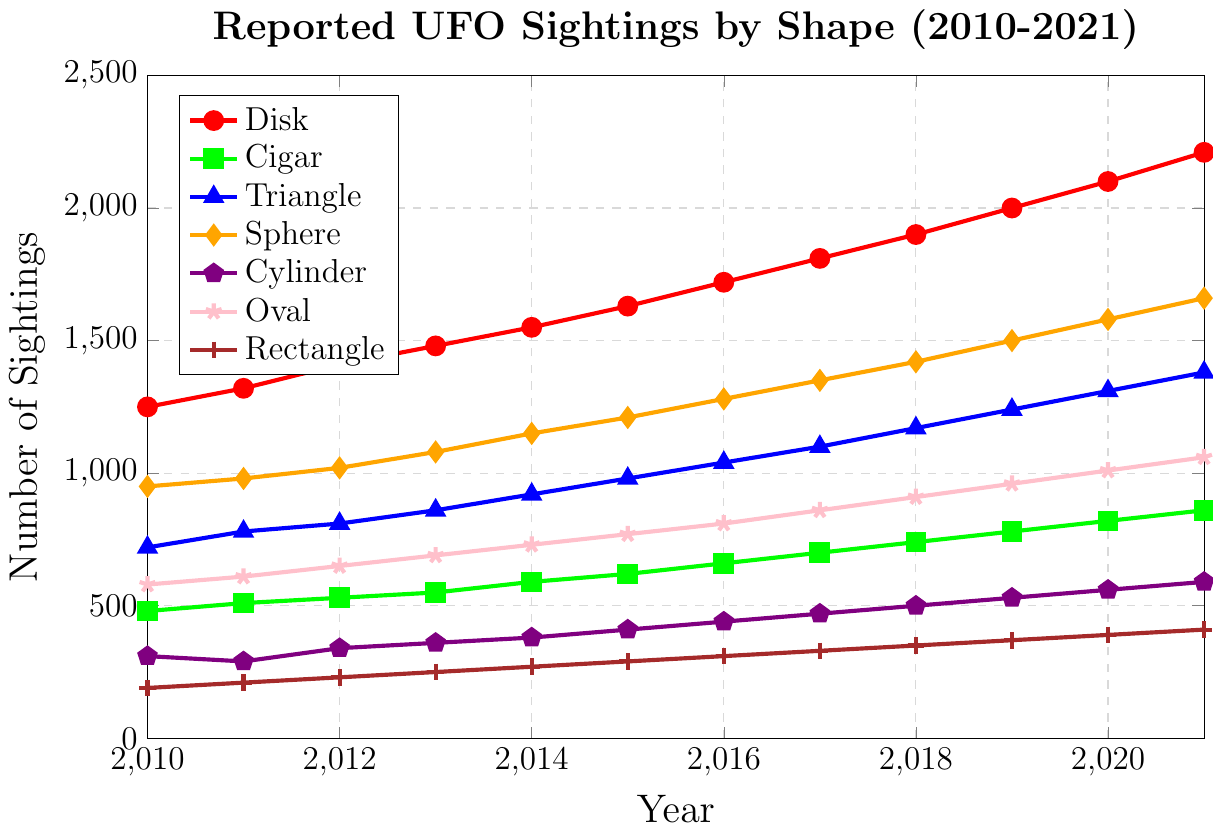What year had the highest number of reported UFO sightings for the "Sphere" shape? To find the year with the highest number of reported UFO sightings for the "Sphere" shape, we look at the values plotted for the "Sphere" and identify the highest point. According to the data, the highest number is 1660 in 2021.
Answer: 2021 Between the years 2015 and 2020, how much did the "Disk" UFO sightings increase by? We look at the values for "Disk" in 2015 and 2020. The number of sightings in 2015 is 1630 and in 2020 it is 2100. The increase is calculated by subtracting the 2015 value from the 2020 value: 2100 - 1630 = 470.
Answer: 470 Which shape of UFO had the least number of sightings in 2013? We need to identify the lowest value among all shapes in 2013. From the data, "Rectangle" had the least number of sightings in 2013 with a value of 250.
Answer: Rectangle What was the average number of reported UFO sightings for the "Cigar" shape from 2010 to 2021? To calculate the average, we first sum the values from 2010 to 2021 for the "Cigar" shape and then divide by the number of years, which is 12. The sum is: 480 + 510 + 530 + 550 + 590 + 620 + 660 + 700 + 740 + 780 + 820 + 860 = 7840. The average is: 7840 / 12 ≈ 653.33.
Answer: 653.33 In which year did the "Oval" shape see its most significant increase in reported sightings compared to the previous year? To find the most significant increase, we calculate the year-on-year differences for the "Oval" shape from one year to the next, and identify the largest difference. The differences are: 
(610-580)=30, 
(650-610)=40,
(690-650)=40,
(730-690)=40,
(770-730)=40,
(810-770)=40,
(860-810)=50,
(910-860)=50,
(960-910)=50,
(1010-960)=50,
(1060-1010)=50.
The largest increase of 50 sightings happened in 2017, 2018, 2019, and 2020, but since 2017 is the earliest among these, we choose it.
Answer: 2017 By how much did the total number of reported UFO sightings across all shapes increase from 2010 to 2021? First, sum the number of sightings across all shapes for both 2010 and 2021. For 2010: 1250 + 480 + 720 + 950 + 310 + 580 + 190 = 4480. For 2021: 2210 + 860 + 1380 + 1660 + 590 + 1060 + 410 = 8170. The increase is: 8170 - 4480 = 3690.
Answer: 3690 Which shape saw the most constant yearly increase in reported sightings? To find the most constant yearly increase, we compare the differences in reported sightings year over year for each shape. Checking all, "Disk" shape has almost regular increases each year (70, 90, 70, 80) and does not vary much compared to others.
Answer: Disk What is the difference in the number of reported "Cylinder" UFO sightings between 2011 and 2010, and how does it compare to the difference between the years 2020 and 2019? First, calculate the differences: for 2011-2010: 290 - 310 = -20. For 2020-2019: 560 - 530 = 30. Compare them: -20 to 30.
Answer: -50 